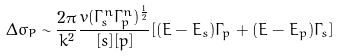Convert formula to latex. <formula><loc_0><loc_0><loc_500><loc_500>\Delta \sigma _ { P } \sim { \frac { 2 { \pi } } { k ^ { 2 } } } { \frac { v { ( \Gamma _ { s } ^ { n } \Gamma _ { p } ^ { n } ) ^ { \frac { 1 } { 2 } } } } { [ s ] [ p ] } } [ ( E - E _ { s } ) \Gamma _ { p } + ( E - E _ { p } ) \Gamma _ { s } ]</formula> 